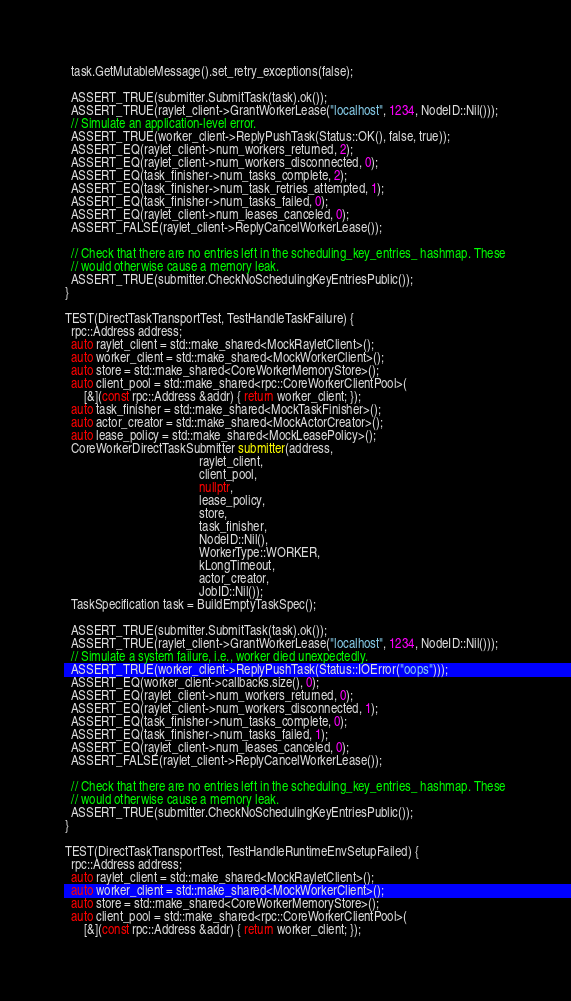Convert code to text. <code><loc_0><loc_0><loc_500><loc_500><_C++_>
  task.GetMutableMessage().set_retry_exceptions(false);

  ASSERT_TRUE(submitter.SubmitTask(task).ok());
  ASSERT_TRUE(raylet_client->GrantWorkerLease("localhost", 1234, NodeID::Nil()));
  // Simulate an application-level error.
  ASSERT_TRUE(worker_client->ReplyPushTask(Status::OK(), false, true));
  ASSERT_EQ(raylet_client->num_workers_returned, 2);
  ASSERT_EQ(raylet_client->num_workers_disconnected, 0);
  ASSERT_EQ(task_finisher->num_tasks_complete, 2);
  ASSERT_EQ(task_finisher->num_task_retries_attempted, 1);
  ASSERT_EQ(task_finisher->num_tasks_failed, 0);
  ASSERT_EQ(raylet_client->num_leases_canceled, 0);
  ASSERT_FALSE(raylet_client->ReplyCancelWorkerLease());

  // Check that there are no entries left in the scheduling_key_entries_ hashmap. These
  // would otherwise cause a memory leak.
  ASSERT_TRUE(submitter.CheckNoSchedulingKeyEntriesPublic());
}

TEST(DirectTaskTransportTest, TestHandleTaskFailure) {
  rpc::Address address;
  auto raylet_client = std::make_shared<MockRayletClient>();
  auto worker_client = std::make_shared<MockWorkerClient>();
  auto store = std::make_shared<CoreWorkerMemoryStore>();
  auto client_pool = std::make_shared<rpc::CoreWorkerClientPool>(
      [&](const rpc::Address &addr) { return worker_client; });
  auto task_finisher = std::make_shared<MockTaskFinisher>();
  auto actor_creator = std::make_shared<MockActorCreator>();
  auto lease_policy = std::make_shared<MockLeasePolicy>();
  CoreWorkerDirectTaskSubmitter submitter(address,
                                          raylet_client,
                                          client_pool,
                                          nullptr,
                                          lease_policy,
                                          store,
                                          task_finisher,
                                          NodeID::Nil(),
                                          WorkerType::WORKER,
                                          kLongTimeout,
                                          actor_creator,
                                          JobID::Nil());
  TaskSpecification task = BuildEmptyTaskSpec();

  ASSERT_TRUE(submitter.SubmitTask(task).ok());
  ASSERT_TRUE(raylet_client->GrantWorkerLease("localhost", 1234, NodeID::Nil()));
  // Simulate a system failure, i.e., worker died unexpectedly.
  ASSERT_TRUE(worker_client->ReplyPushTask(Status::IOError("oops")));
  ASSERT_EQ(worker_client->callbacks.size(), 0);
  ASSERT_EQ(raylet_client->num_workers_returned, 0);
  ASSERT_EQ(raylet_client->num_workers_disconnected, 1);
  ASSERT_EQ(task_finisher->num_tasks_complete, 0);
  ASSERT_EQ(task_finisher->num_tasks_failed, 1);
  ASSERT_EQ(raylet_client->num_leases_canceled, 0);
  ASSERT_FALSE(raylet_client->ReplyCancelWorkerLease());

  // Check that there are no entries left in the scheduling_key_entries_ hashmap. These
  // would otherwise cause a memory leak.
  ASSERT_TRUE(submitter.CheckNoSchedulingKeyEntriesPublic());
}

TEST(DirectTaskTransportTest, TestHandleRuntimeEnvSetupFailed) {
  rpc::Address address;
  auto raylet_client = std::make_shared<MockRayletClient>();
  auto worker_client = std::make_shared<MockWorkerClient>();
  auto store = std::make_shared<CoreWorkerMemoryStore>();
  auto client_pool = std::make_shared<rpc::CoreWorkerClientPool>(
      [&](const rpc::Address &addr) { return worker_client; });</code> 